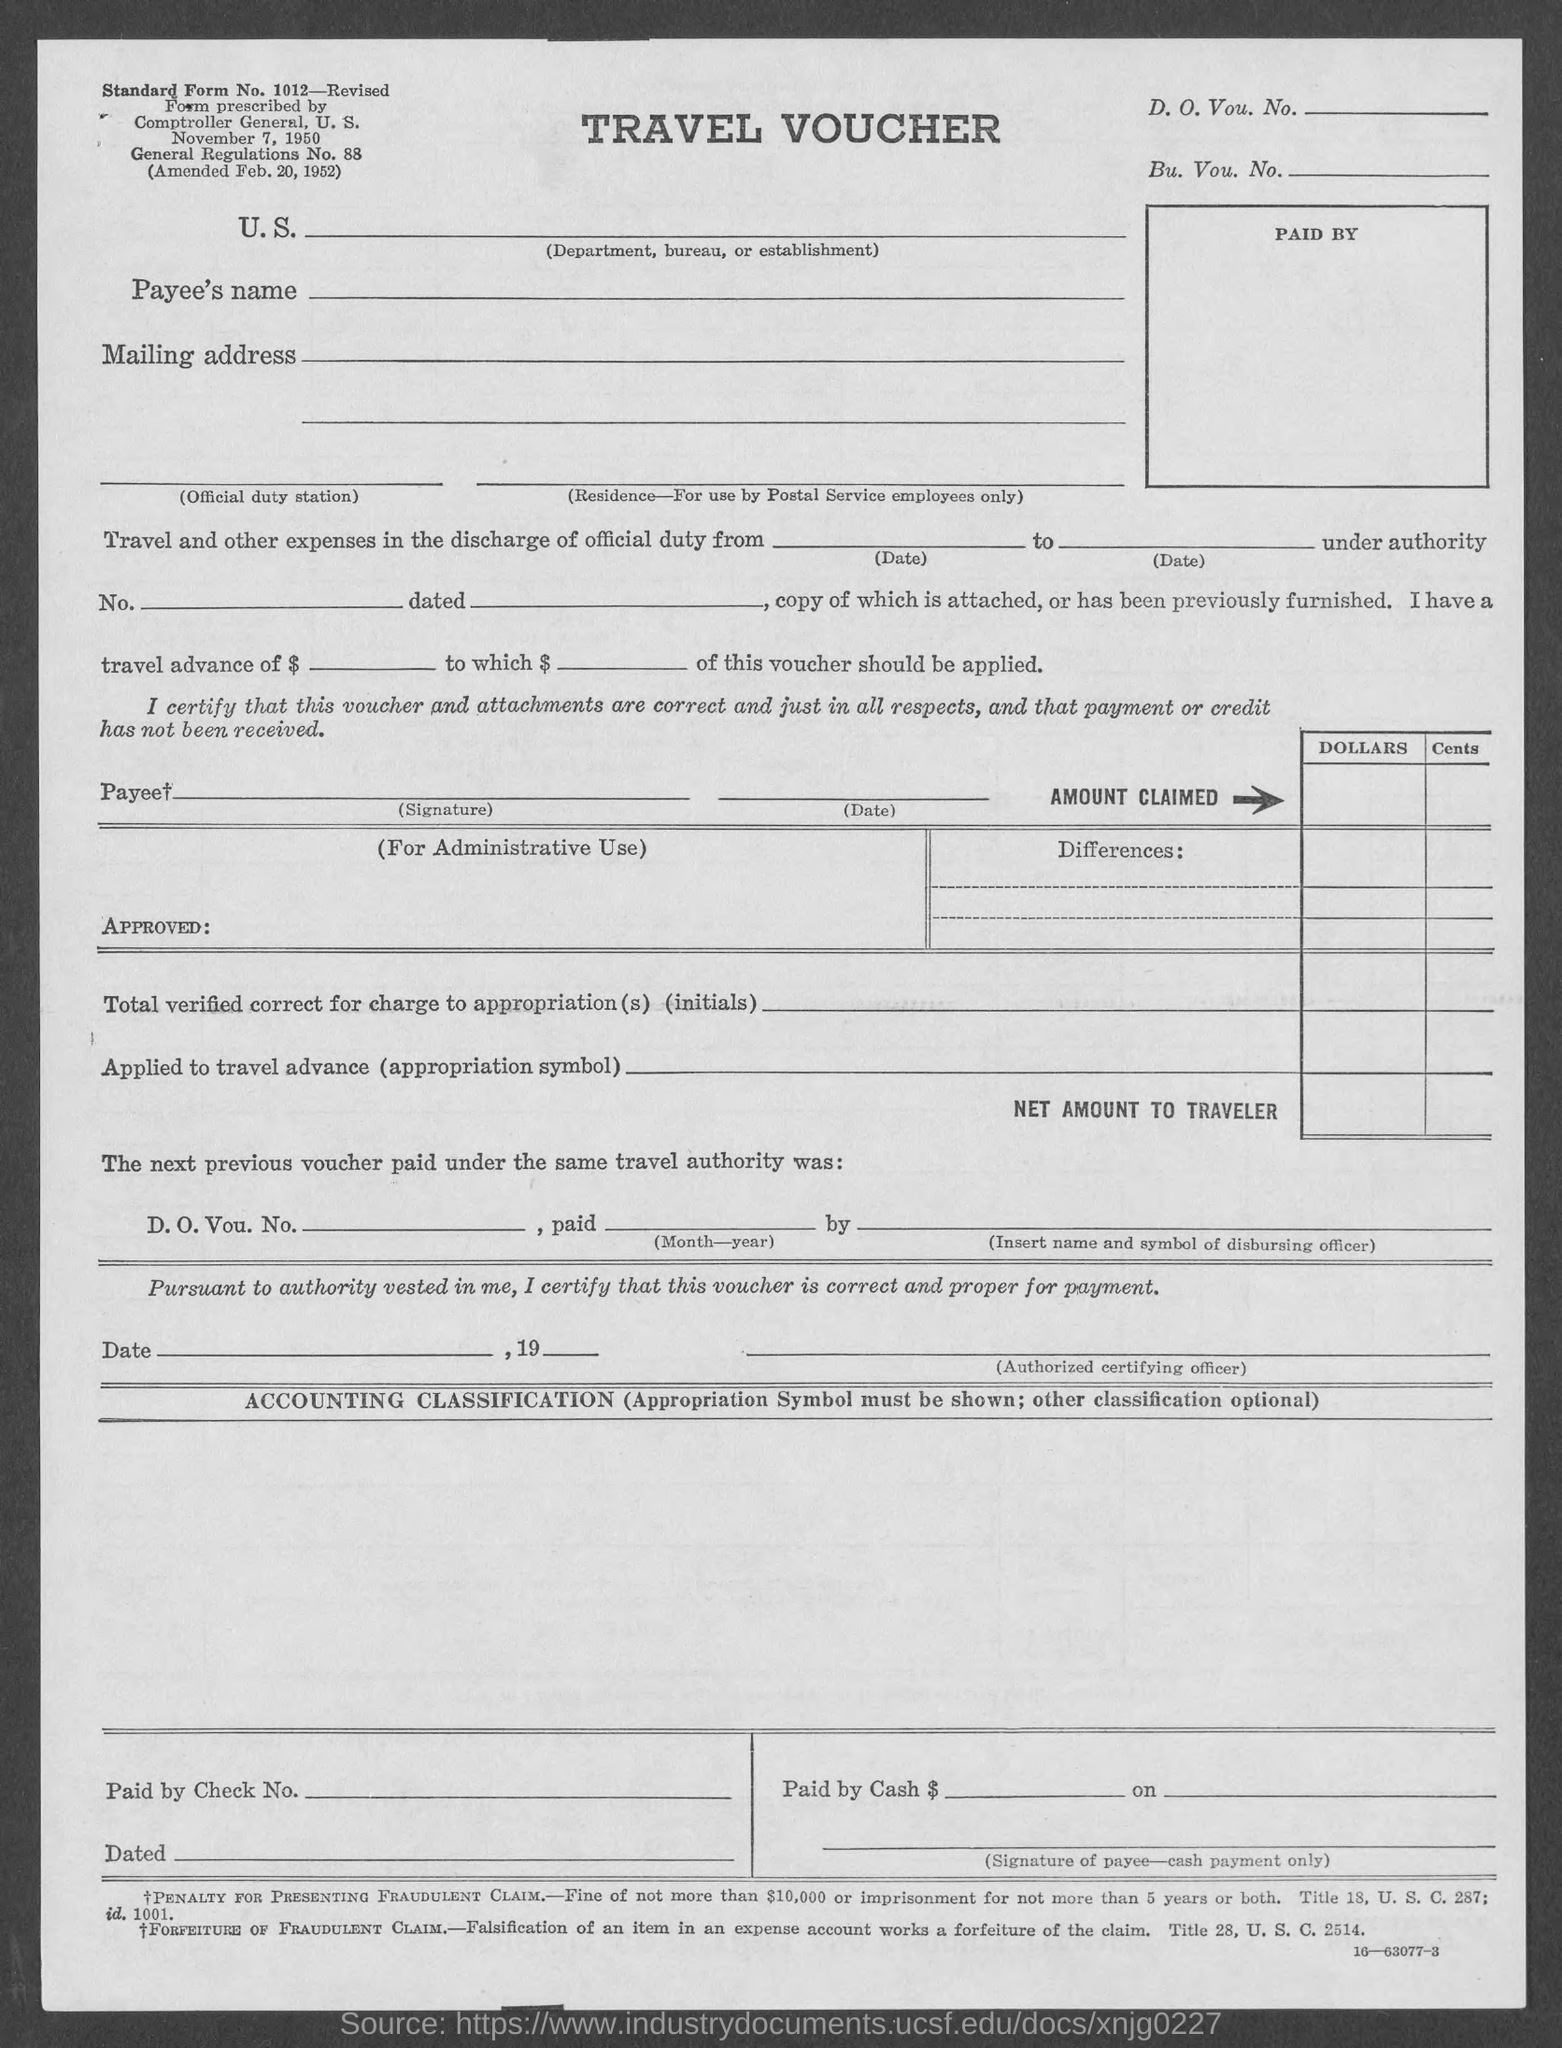What is the standard form no. mentioned in the given page ?
Offer a terse response. 1012 - Revised. 